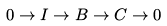Convert formula to latex. <formula><loc_0><loc_0><loc_500><loc_500>0 \rightarrow I \rightarrow B \rightarrow C \rightarrow 0</formula> 